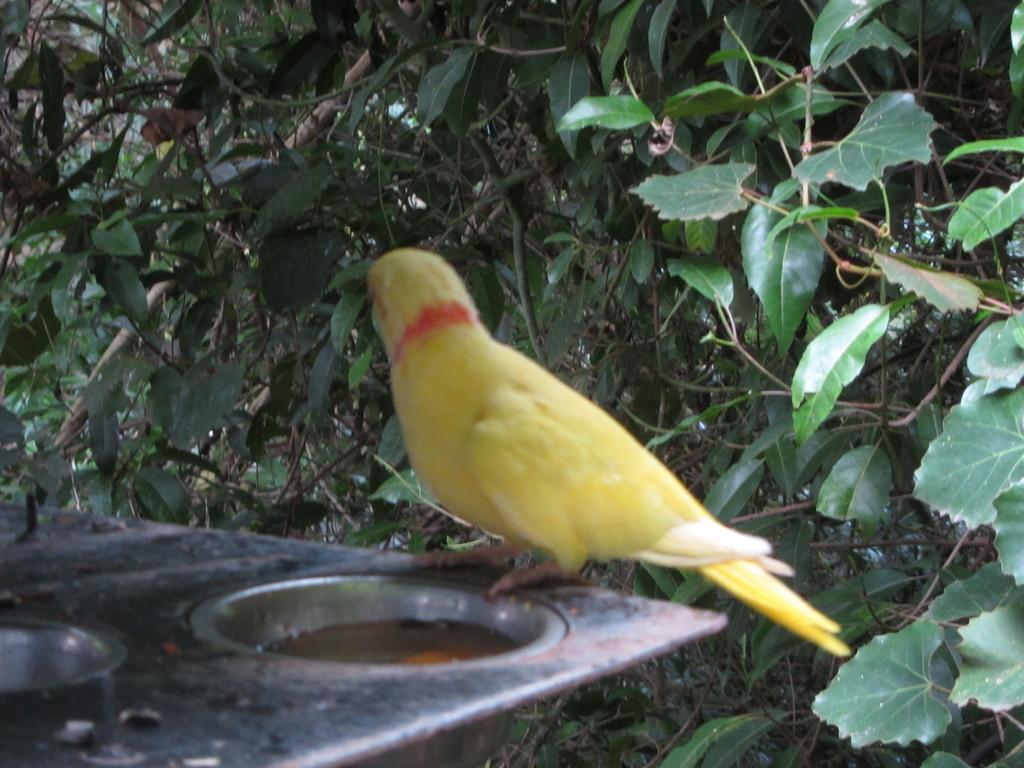How would you summarize this image in a sentence or two? In the image there is a bird standing on an object and around the bird there are many branches of a tree. 